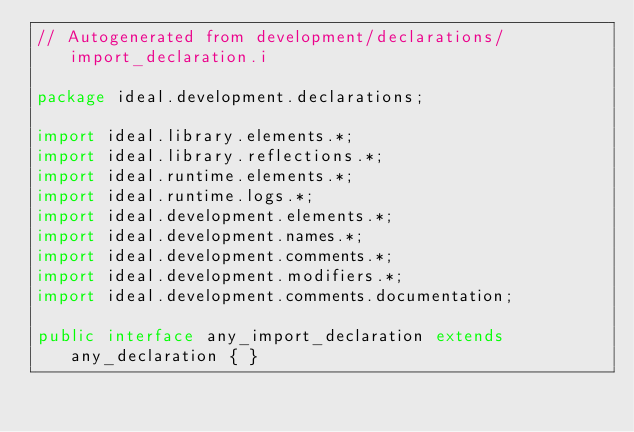<code> <loc_0><loc_0><loc_500><loc_500><_Java_>// Autogenerated from development/declarations/import_declaration.i

package ideal.development.declarations;

import ideal.library.elements.*;
import ideal.library.reflections.*;
import ideal.runtime.elements.*;
import ideal.runtime.logs.*;
import ideal.development.elements.*;
import ideal.development.names.*;
import ideal.development.comments.*;
import ideal.development.modifiers.*;
import ideal.development.comments.documentation;

public interface any_import_declaration extends any_declaration { }
</code> 